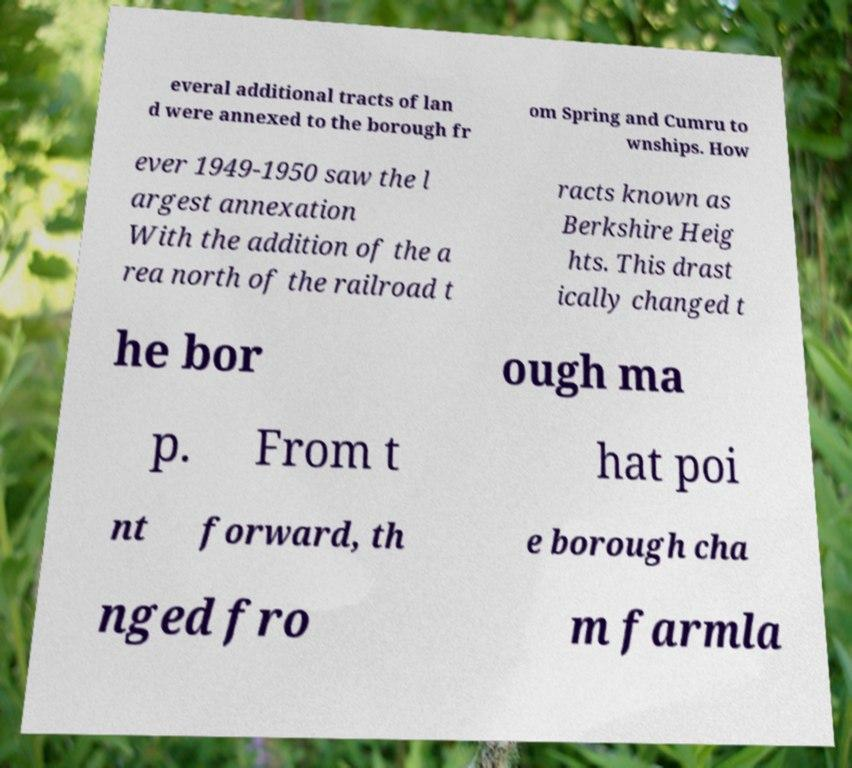I need the written content from this picture converted into text. Can you do that? everal additional tracts of lan d were annexed to the borough fr om Spring and Cumru to wnships. How ever 1949-1950 saw the l argest annexation With the addition of the a rea north of the railroad t racts known as Berkshire Heig hts. This drast ically changed t he bor ough ma p. From t hat poi nt forward, th e borough cha nged fro m farmla 